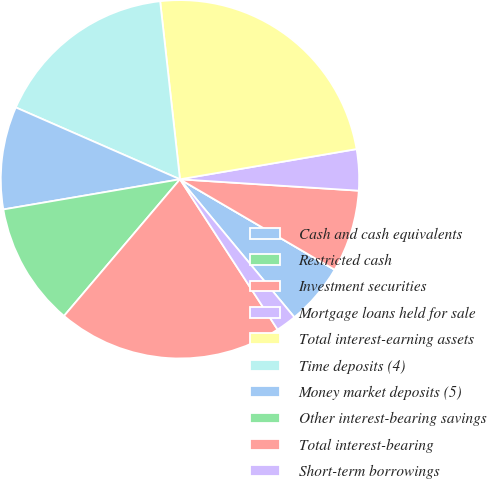Convert chart to OTSL. <chart><loc_0><loc_0><loc_500><loc_500><pie_chart><fcel>Cash and cash equivalents<fcel>Restricted cash<fcel>Investment securities<fcel>Mortgage loans held for sale<fcel>Total interest-earning assets<fcel>Time deposits (4)<fcel>Money market deposits (5)<fcel>Other interest-bearing savings<fcel>Total interest-bearing<fcel>Short-term borrowings<nl><fcel>5.56%<fcel>0.0%<fcel>7.41%<fcel>3.71%<fcel>24.07%<fcel>16.67%<fcel>9.26%<fcel>11.11%<fcel>20.37%<fcel>1.85%<nl></chart> 